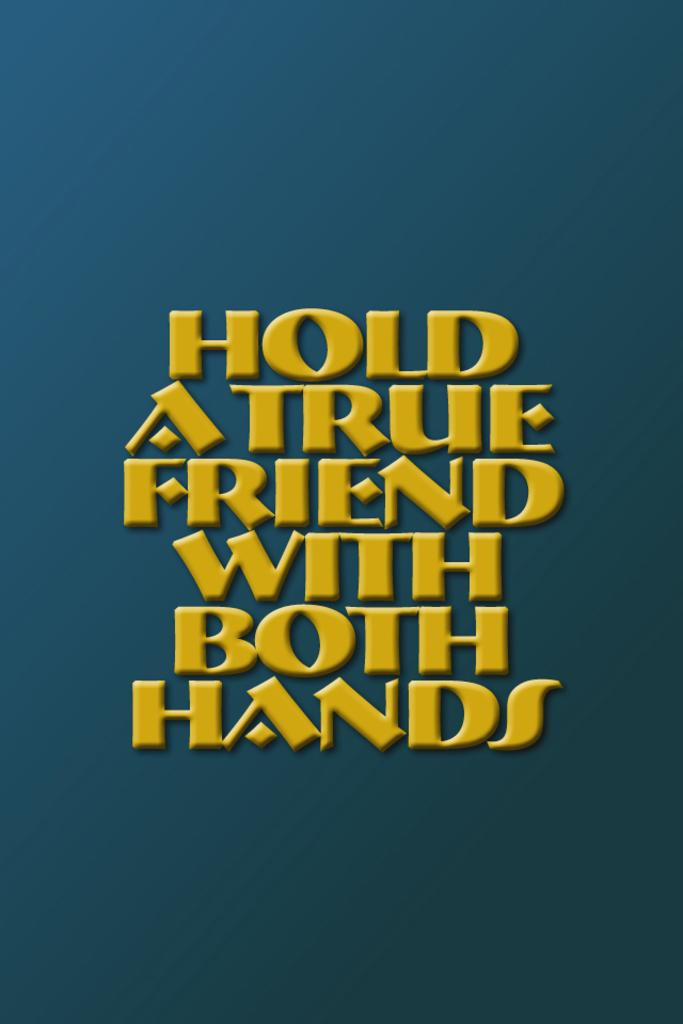Provide a one-sentence caption for the provided image. a blue and yellow sign that read hold a true friend with both hands. 